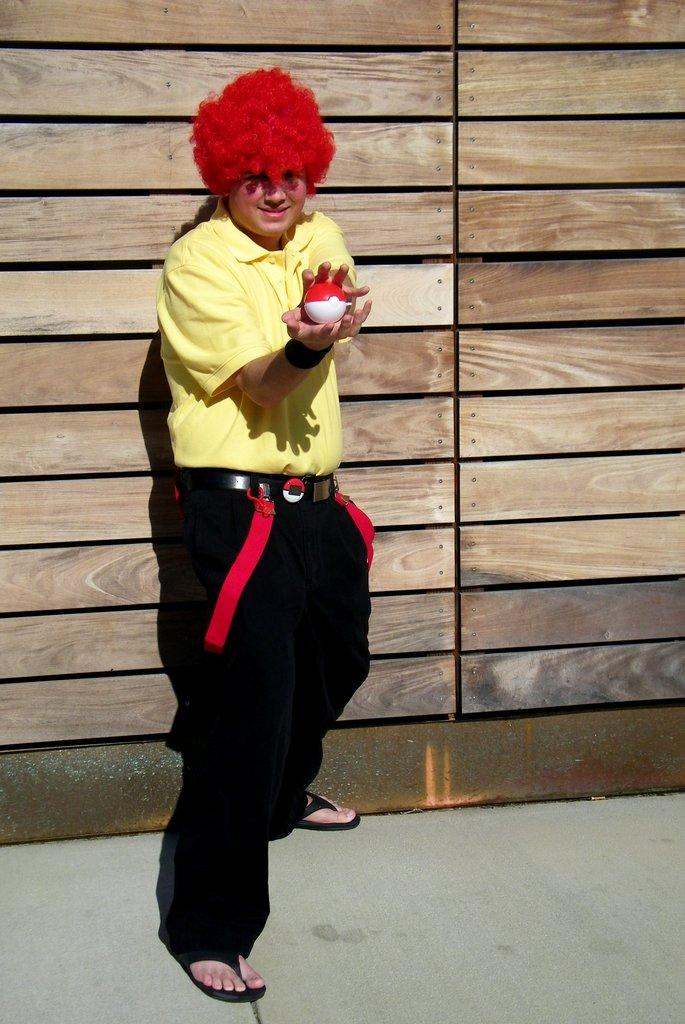What can be seen in the image? There is a person in the image. What is the person doing in the image? The person is holding an object and standing on the floor. What can be seen in the background of the image? There is a wooden wall in the background of the image. What type of treatment is the person receiving in the image? There is no indication in the image that the person is receiving any treatment. 